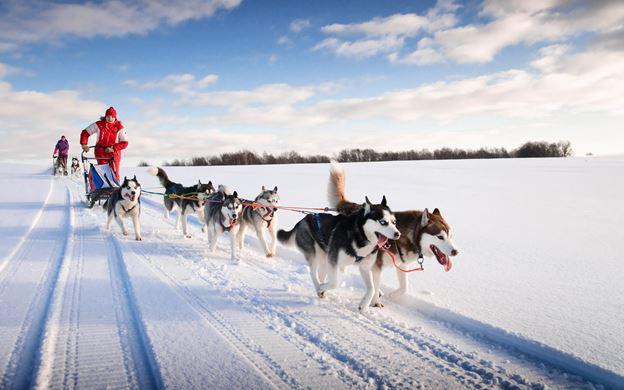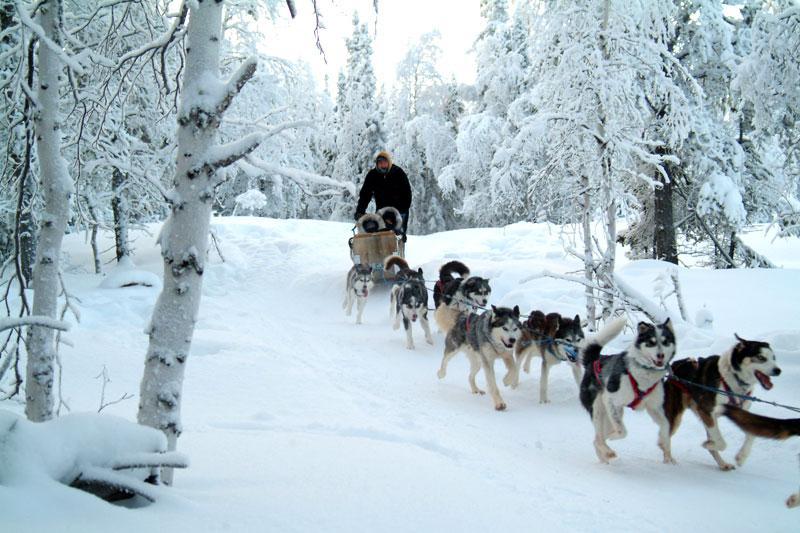The first image is the image on the left, the second image is the image on the right. Considering the images on both sides, is "There are no trees behind the dogs in at least one of the images." valid? Answer yes or no. No. 